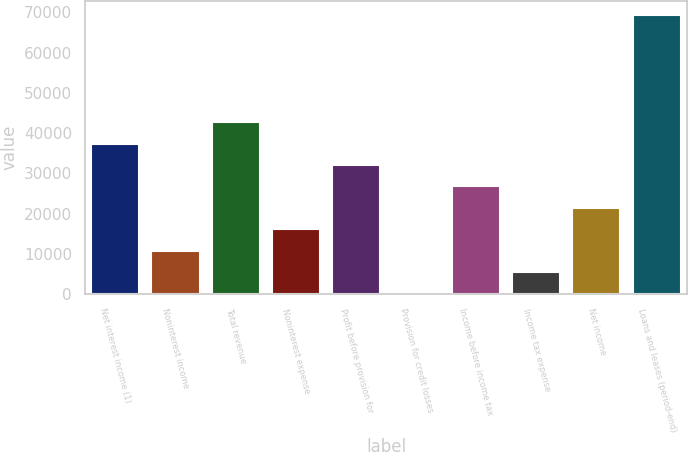<chart> <loc_0><loc_0><loc_500><loc_500><bar_chart><fcel>Net interest income (1)<fcel>Noninterest income<fcel>Total revenue<fcel>Noninterest expense<fcel>Profit before provision for<fcel>Provision for credit losses<fcel>Income before income tax<fcel>Income tax expense<fcel>Net income<fcel>Loans and leases (period-end)<nl><fcel>37415.1<fcel>10708.6<fcel>42756.4<fcel>16049.9<fcel>32073.8<fcel>26<fcel>26732.5<fcel>5367.3<fcel>21391.2<fcel>69462.9<nl></chart> 